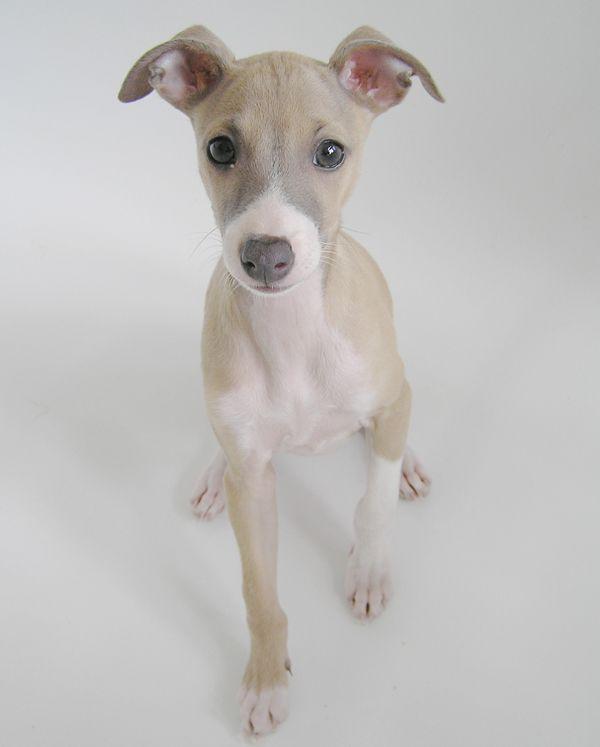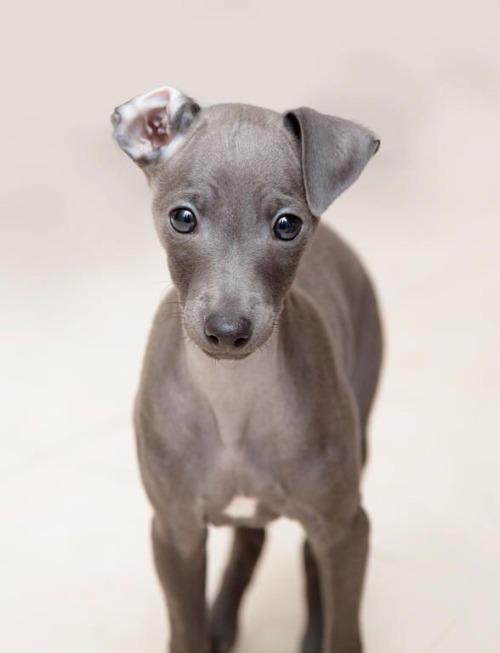The first image is the image on the left, the second image is the image on the right. Given the left and right images, does the statement "At least two dogs have gray faces." hold true? Answer yes or no. No. The first image is the image on the left, the second image is the image on the right. Given the left and right images, does the statement "there is a solid gray dog with no white patches in one of the images." hold true? Answer yes or no. Yes. 